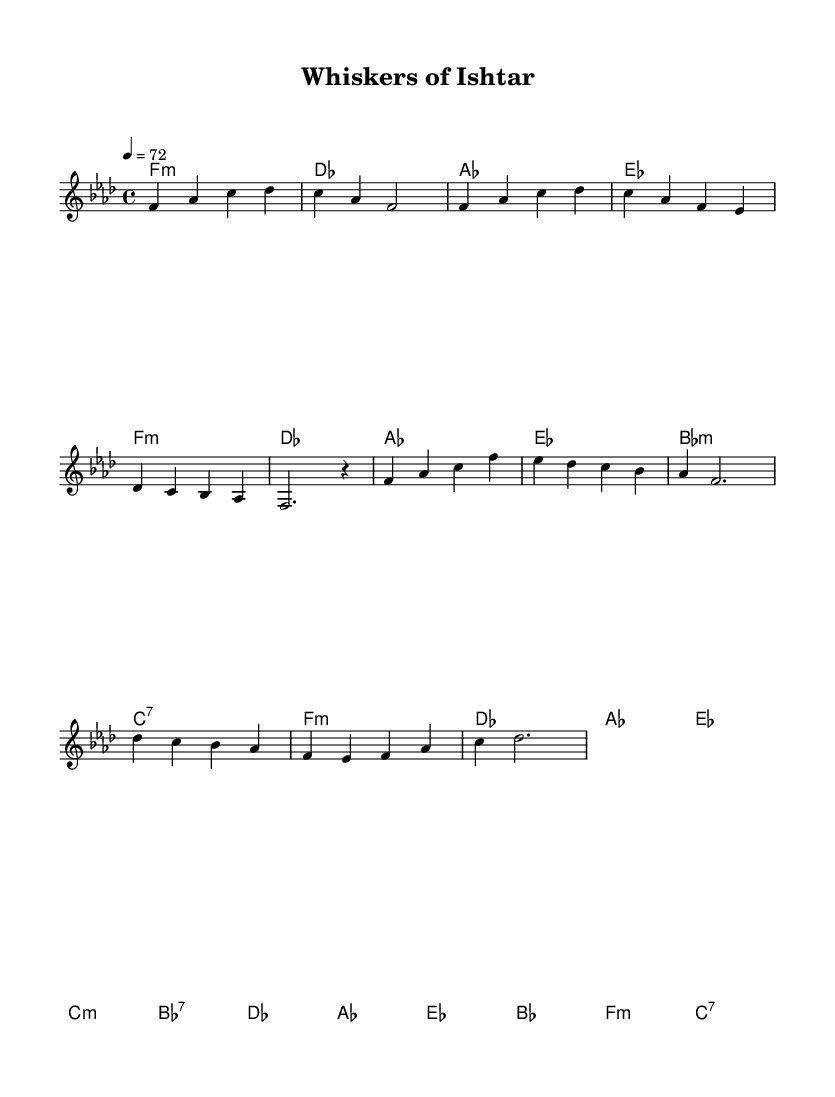What is the key signature of this music? The key signature is indicated at the beginning of the score. In this case, it shows that there are four flats, which corresponds to the key of F minor.
Answer: F minor What is the time signature of this music? The time signature is found at the beginning of the score, represented by the numbers 4 and 4. This indicates that there are four beats in each measure and a quarter note receives one beat.
Answer: 4/4 What is the tempo marking of this piece? The tempo marking is indicated in the score as "4 = 72". This means that there are 72 beats per minute.
Answer: 72 How many measures are in the chorus section? To find this, we look at the chorus part of the music. The chorus consists of the measures that follow the "Chorus" label, totaling four measures.
Answer: 4 What chords are used in the bridge section? By examining the chord symbols in the harmonies section under the bridge label, we can see that the chords are des, aes, ees, bes, f, and c.
Answer: des, aes, ees, bes, f, c What is a prominent theme in the lyrics of Rhythm and Blues ballads reflected in this piece? Rhythm and Blues ballads often revolve around love, longing, or mythology. Given the title "Whiskers of Ishtar," it likely draws on themes of love or devotion associated with the Mesopotamian goddess Ishtar.
Answer: Love 